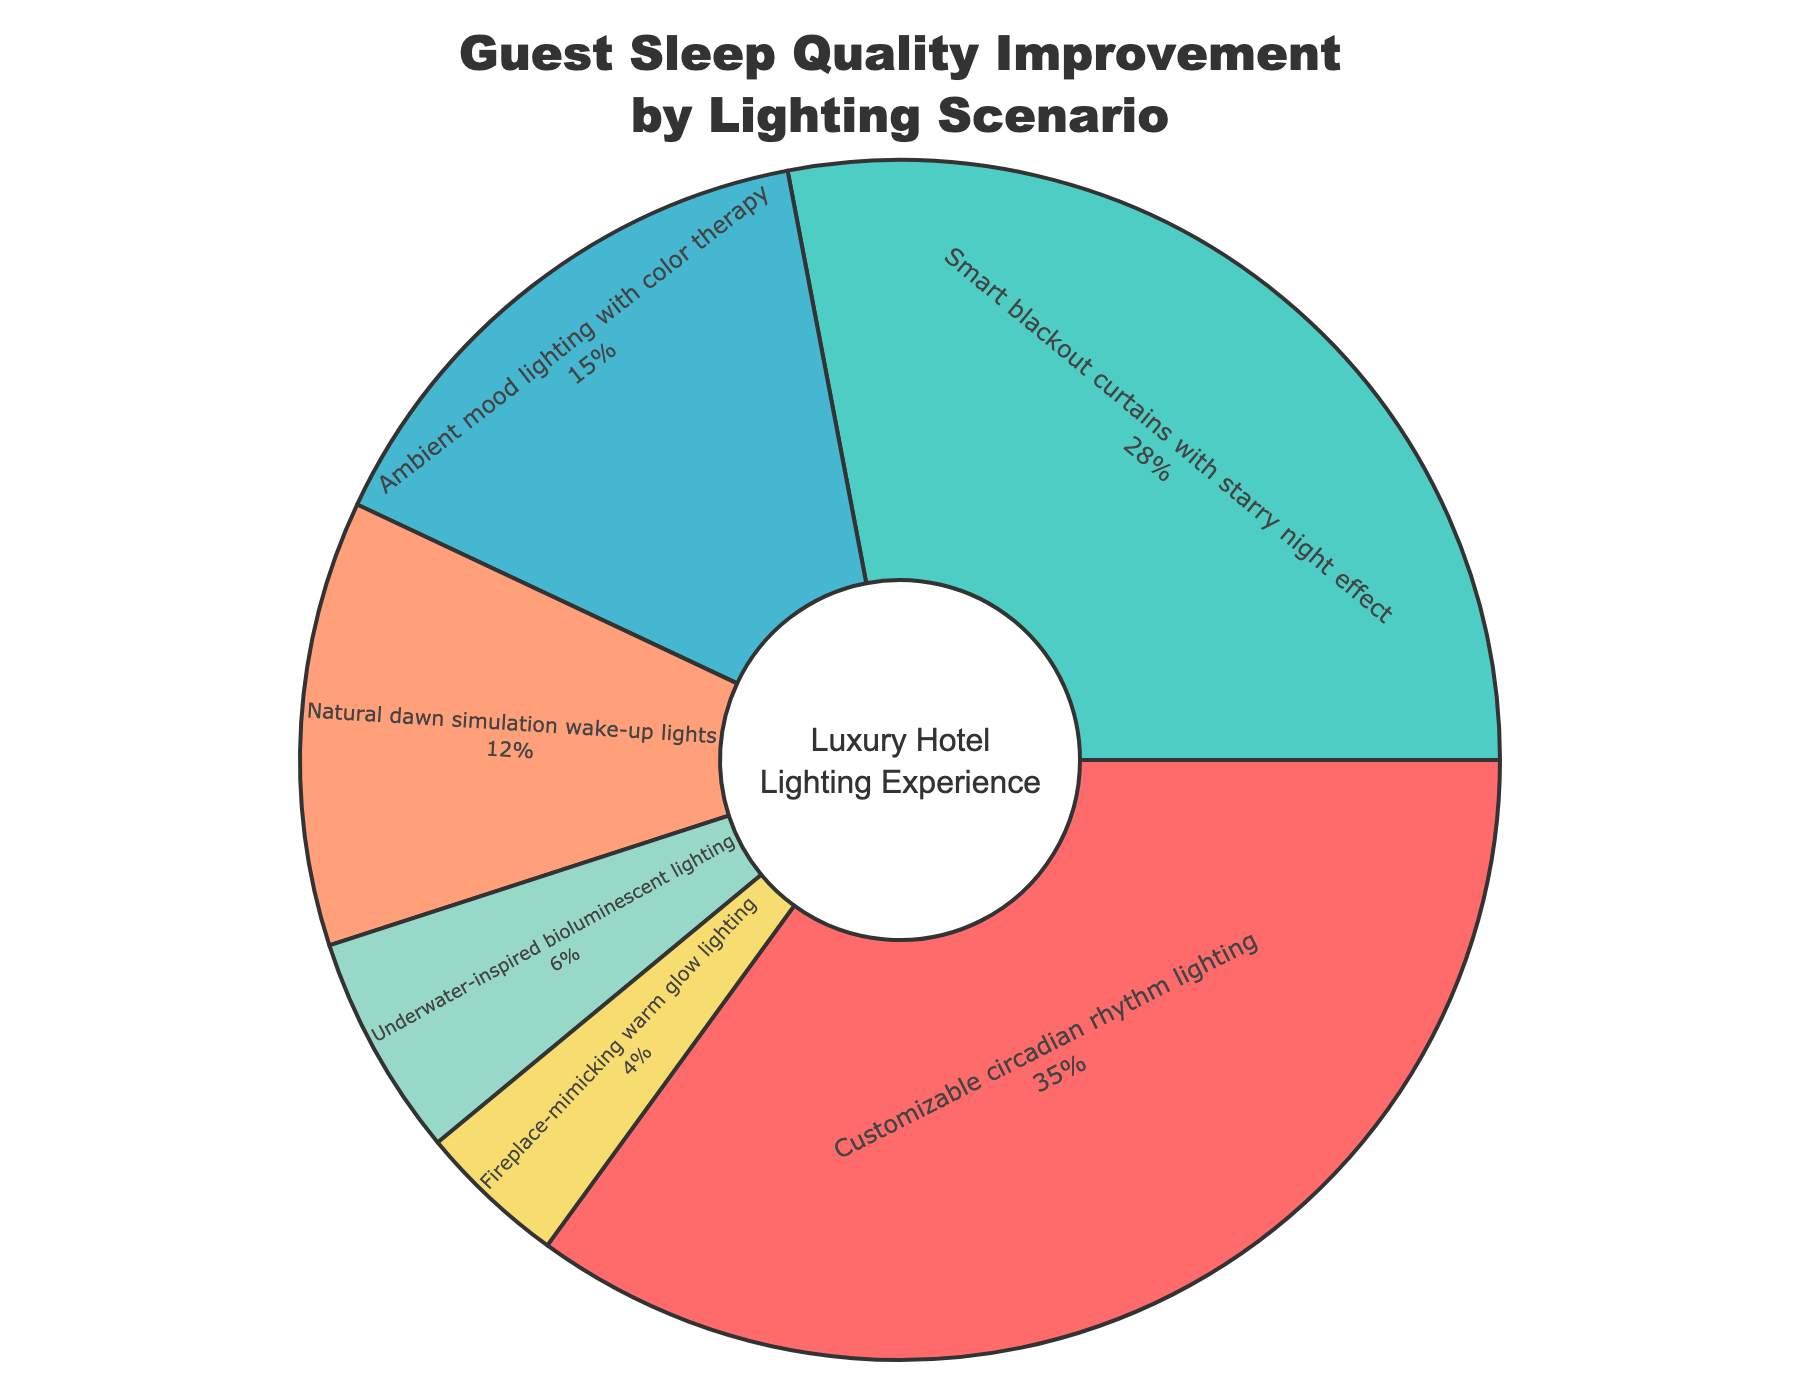Which lighting scenario is reported to have the highest percentage of improved sleep quality? To find the highest percentage, look at the slice that occupies the largest portion of the pie chart.
Answer: Customizable circadian rhythm lighting How much more percentage of guests reported improved sleep quality with smart blackout curtains compared to natural dawn simulation wake-up lights? Subtract the smaller percentage (natural dawn simulation wake-up lights: 12%) from the larger percentage (smart blackout curtains: 28%).
Answer: 16% How do the combined percentages of ambient mood lighting and underwater-inspired bioluminescent lighting compare with customizable circadian rhythm lighting? Add the percentages for ambient mood lighting (15%) and underwater-inspired bioluminescent lighting (6%) and compare the sum to the percentage for customizable circadian rhythm lighting (35%).
Answer: 21% (combined), less than 35% Which lighting scenario has the lowest percentage of reported sleep quality improvement? Identify the smallest slice in the pie chart.
Answer: Fireplace-mimicking warm glow lighting What is the sum of the percentages of the top two lighting scenarios? Add the percentages of the top two lighting scenarios: customizable circadian rhythm lighting (35%) and smart blackout curtains (28%).
Answer: 63% Consider the cumulative percentage of the three least popular lighting scenarios. What is it? Add the percentages of the three least reported scenarios: underwater-inspired bioluminescent lighting (6%), fireplace-mimicking warm glow lighting (4%), and natural dawn simulation wake-up lights (12%).
Answer: 22% How does the percentage of guests reporting improved sleep quality with smart blackout curtains compare to those with natural dawn simulation wake-up lights and ambient mood lighting combined? Calculate the sum of natural dawn simulation wake-up lights (12%) and ambient mood lighting (15%), and compare it to the percentage for smart blackout curtains (28%).
Answer: 27%, less than 28% What percentage of guests reported improved sleep quality with lighting scenarios offering bioluminescent and color therapy elements combined? Add the percentages for underwater-inspired bioluminescent lighting (6%) and ambient mood lighting with color therapy (15%).
Answer: 21% How many lighting scenarios report a higher percentage of improved sleep quality than natural dawn simulation wake-up lights? Identify all scenarios with percentages higher than 12%.
Answer: Three scenarios (customizable circadian rhythm lighting, smart blackout curtains, ambient mood lighting) 